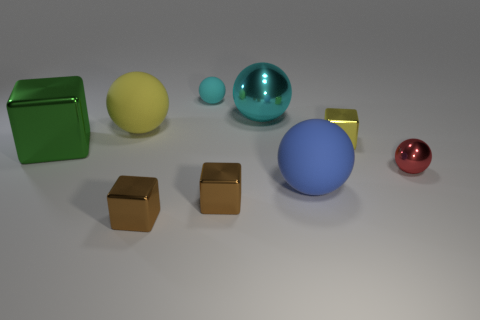Is there a big yellow object made of the same material as the yellow block?
Your response must be concise. No. What number of green things are balls or large shiny things?
Your answer should be compact. 1. Are there more big objects in front of the tiny yellow metal block than things?
Your response must be concise. No. Does the red object have the same size as the cyan matte thing?
Keep it short and to the point. Yes. What is the color of the tiny object that is made of the same material as the blue sphere?
Your answer should be compact. Cyan. There is another object that is the same color as the tiny matte thing; what is its shape?
Give a very brief answer. Sphere. Is the number of red shiny things that are in front of the large blue rubber ball the same as the number of green shiny objects behind the cyan matte thing?
Ensure brevity in your answer.  Yes. The yellow object that is on the left side of the tiny brown shiny thing left of the tiny rubber sphere is what shape?
Provide a succinct answer. Sphere. There is a large cyan thing that is the same shape as the big yellow thing; what is its material?
Provide a succinct answer. Metal. What color is the other rubber sphere that is the same size as the blue matte ball?
Provide a succinct answer. Yellow. 